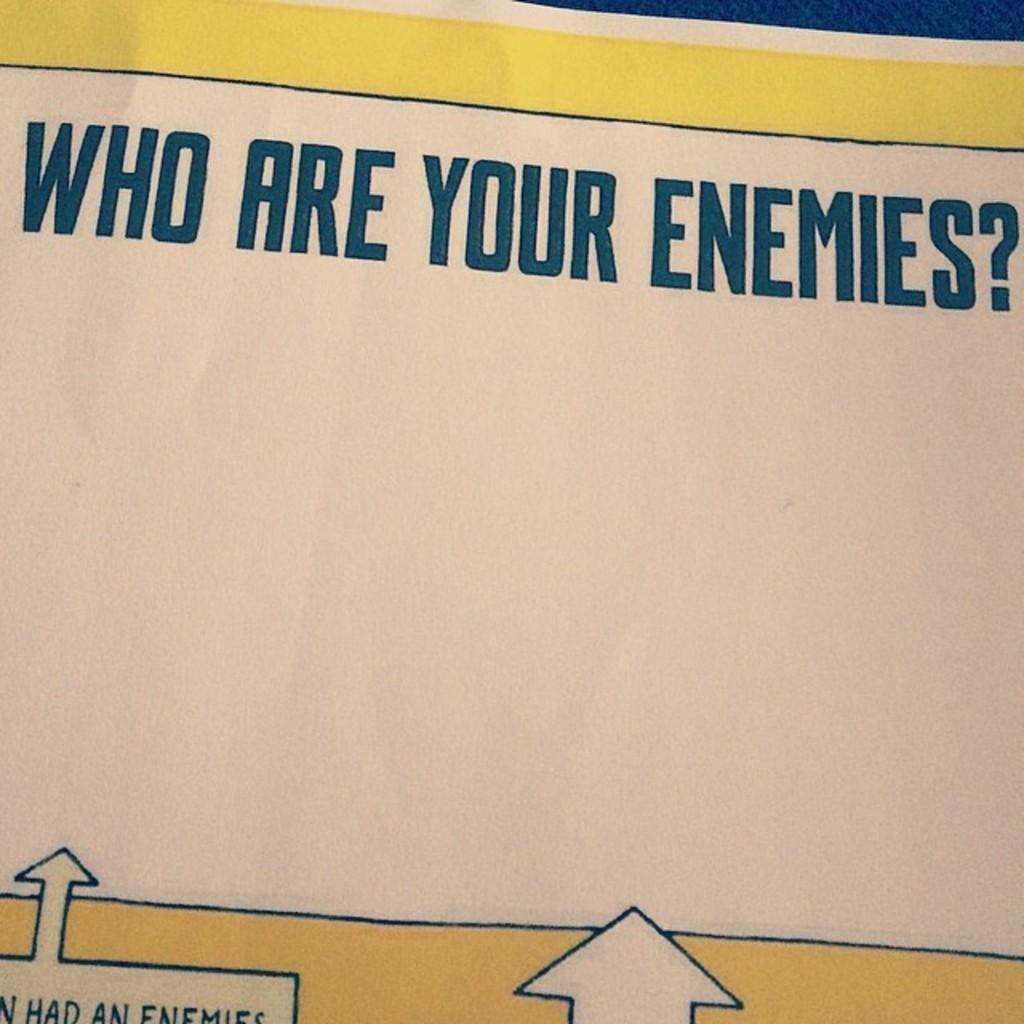Provide a one-sentence caption for the provided image. A yellow and white sign that reads Who are your enemies in large blue letters. 